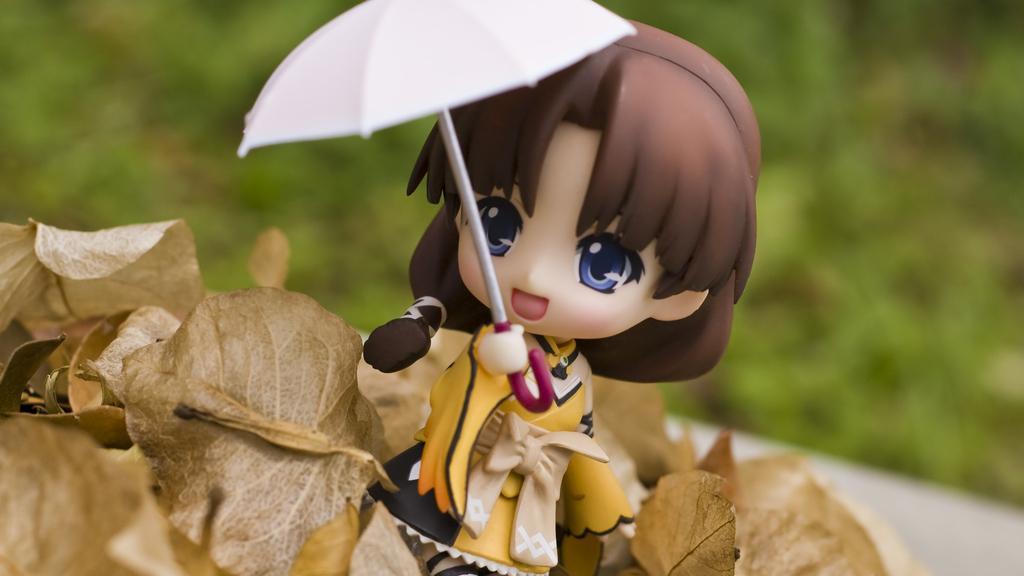Can you describe this image briefly? This image is taken outdoors. In the background there are a few plants with green leaves. At the bottom of the image there are a few dry leaves. In the middle of the image there is a toy with a toy umbrella. 